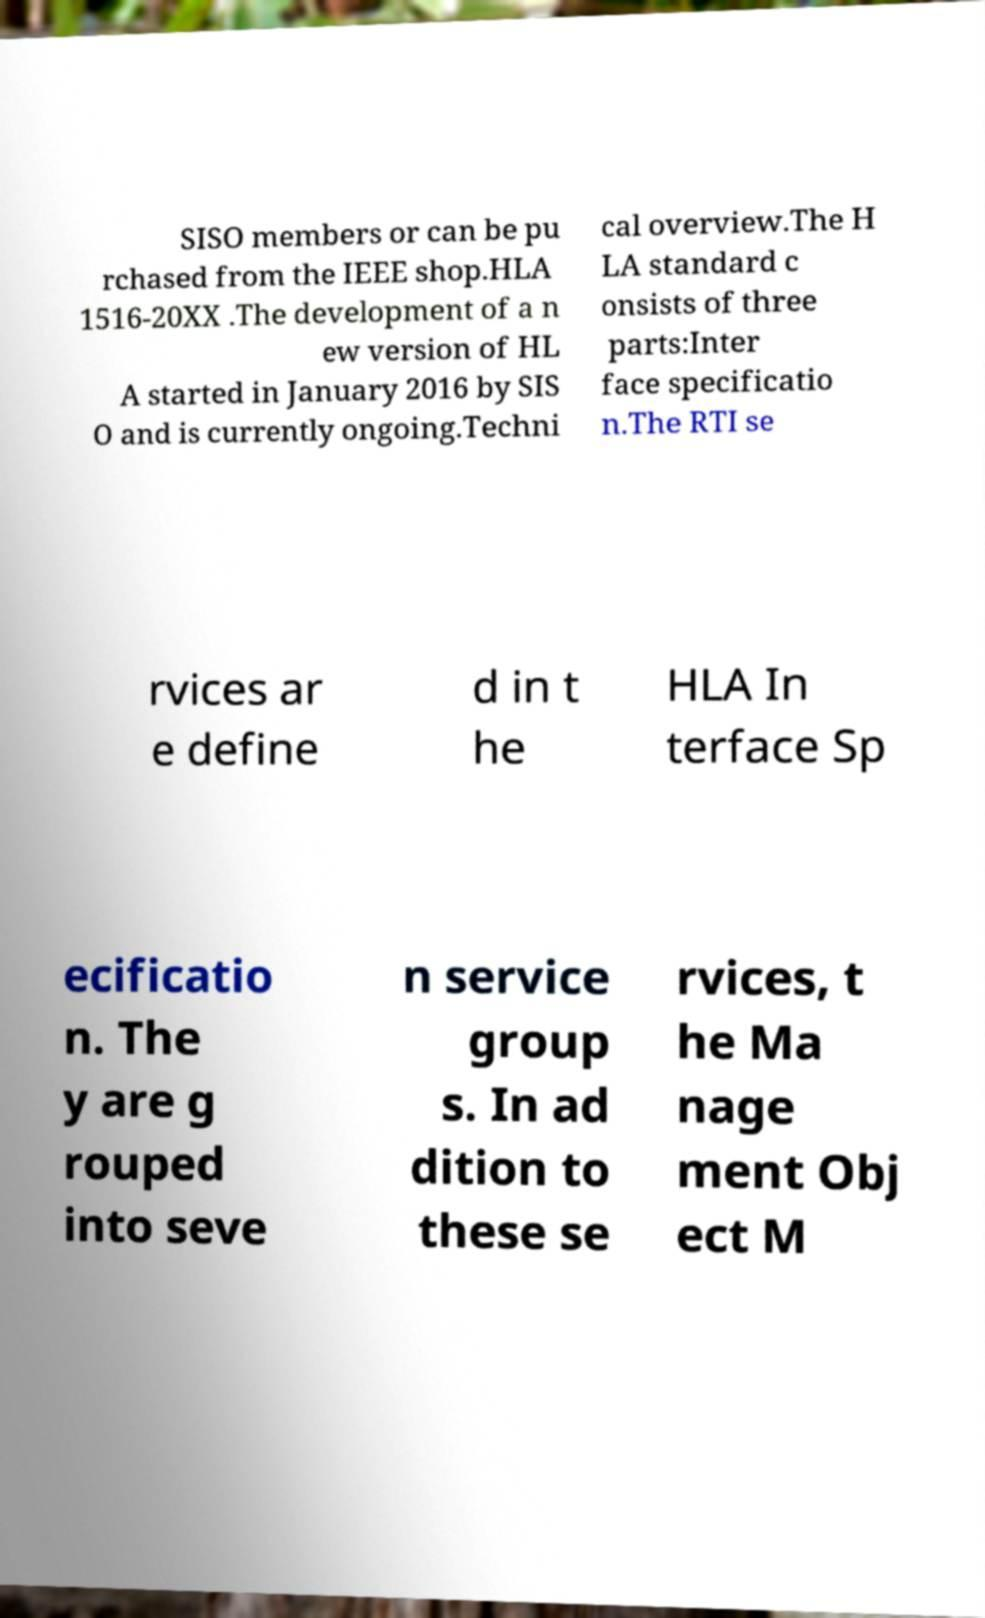For documentation purposes, I need the text within this image transcribed. Could you provide that? SISO members or can be pu rchased from the IEEE shop.HLA 1516-20XX .The development of a n ew version of HL A started in January 2016 by SIS O and is currently ongoing.Techni cal overview.The H LA standard c onsists of three parts:Inter face specificatio n.The RTI se rvices ar e define d in t he HLA In terface Sp ecificatio n. The y are g rouped into seve n service group s. In ad dition to these se rvices, t he Ma nage ment Obj ect M 